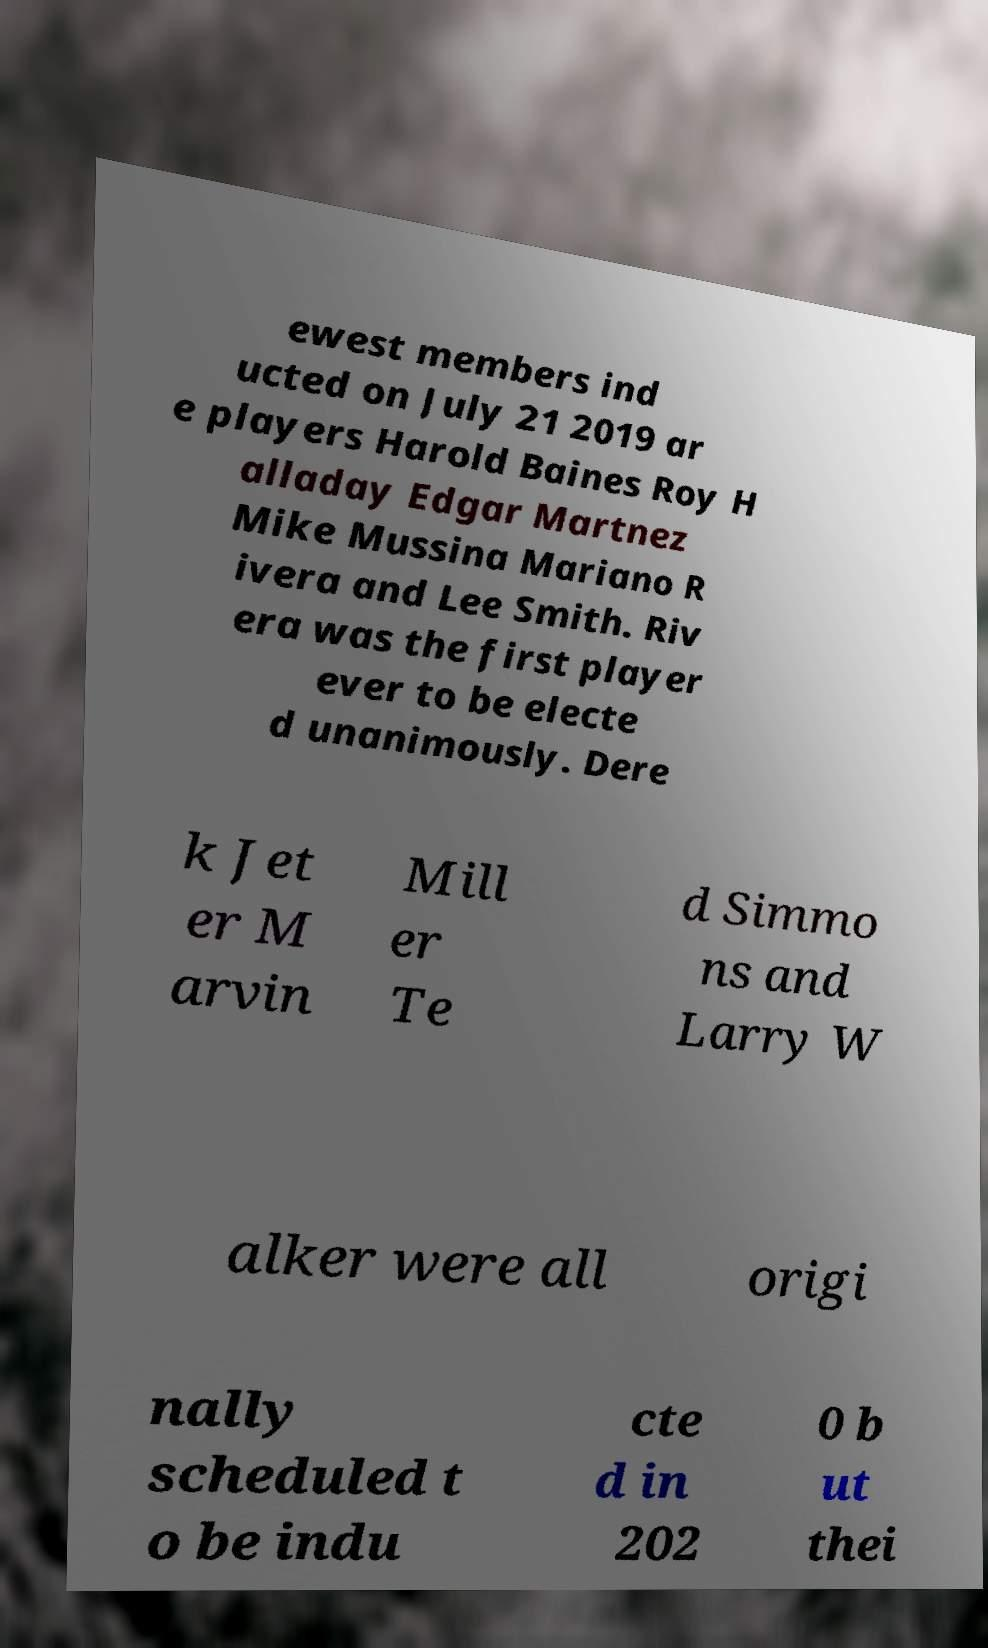I need the written content from this picture converted into text. Can you do that? ewest members ind ucted on July 21 2019 ar e players Harold Baines Roy H alladay Edgar Martnez Mike Mussina Mariano R ivera and Lee Smith. Riv era was the first player ever to be electe d unanimously. Dere k Jet er M arvin Mill er Te d Simmo ns and Larry W alker were all origi nally scheduled t o be indu cte d in 202 0 b ut thei 